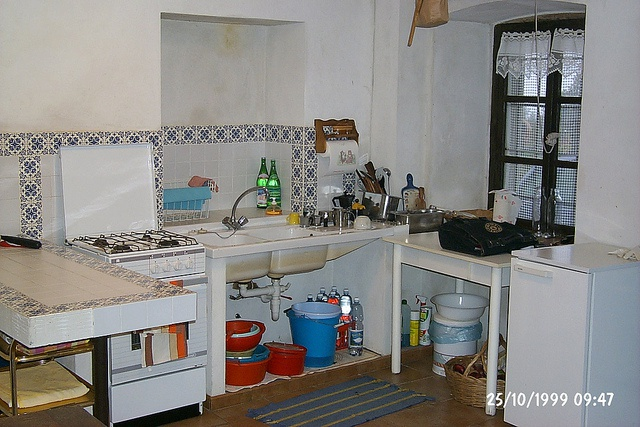Describe the objects in this image and their specific colors. I can see refrigerator in darkgray, gray, and lightgray tones, oven in darkgray, gray, black, and lightgray tones, handbag in darkgray, black, and gray tones, sink in darkgray, gray, and lightgray tones, and bowl in darkgray and gray tones in this image. 